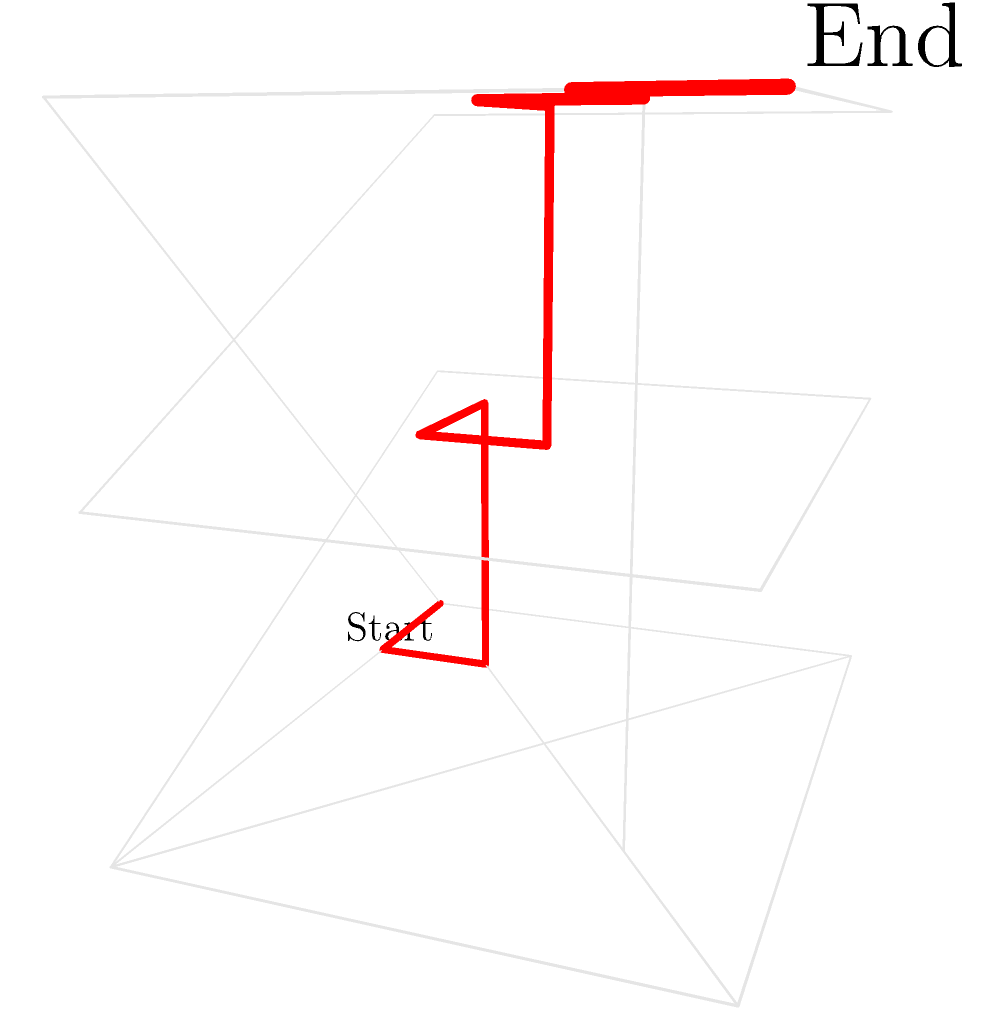In the 3D maze representing layers of government bureaucracy, where each level represents a different tier of government (local, state, and federal), what is the minimum number of steps required to navigate from the start point (local level) to the end point (federal level)? To solve this problem, we need to analyze the 3D maze and find the shortest path from the start to the end point. Let's break it down step-by-step:

1. The maze is represented as a 3D grid with dimensions 4x4x3, where:
   - x-axis (red) represents local level
   - y-axis (green) represents state level
   - z-axis (blue) represents federal level

2. The start point is at (0,0,0), which is the bottom-left corner of the local level.

3. The end point is at (4,4,2), which is the top-right corner of the federal level.

4. We need to navigate through the maze, avoiding walls and finding the shortest path.

5. The optimal path, highlighted in red, is as follows:
   (0,0,0) → (1,0,0) → (1,1,0) → (1,1,1) → (2,1,1) → (2,2,1) → (2,2,2) → (3,2,2) → (3,3,2) → (4,3,2) → (4,4,2)

6. Counting the number of steps (movements) in this path:
   - 2 steps at the local level
   - 3 steps at the state level
   - 5 steps at the federal level

7. The total number of steps in the optimal path is 2 + 3 + 5 = 10.

Therefore, the minimum number of steps required to navigate from the start point to the end point is 10.
Answer: 10 steps 